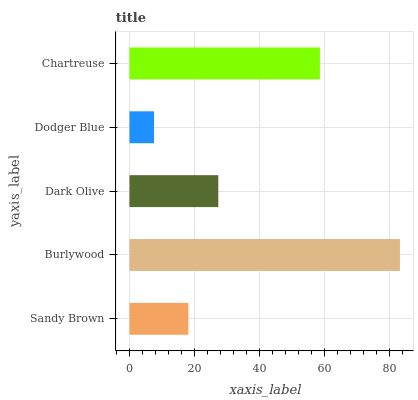Is Dodger Blue the minimum?
Answer yes or no. Yes. Is Burlywood the maximum?
Answer yes or no. Yes. Is Dark Olive the minimum?
Answer yes or no. No. Is Dark Olive the maximum?
Answer yes or no. No. Is Burlywood greater than Dark Olive?
Answer yes or no. Yes. Is Dark Olive less than Burlywood?
Answer yes or no. Yes. Is Dark Olive greater than Burlywood?
Answer yes or no. No. Is Burlywood less than Dark Olive?
Answer yes or no. No. Is Dark Olive the high median?
Answer yes or no. Yes. Is Dark Olive the low median?
Answer yes or no. Yes. Is Sandy Brown the high median?
Answer yes or no. No. Is Chartreuse the low median?
Answer yes or no. No. 